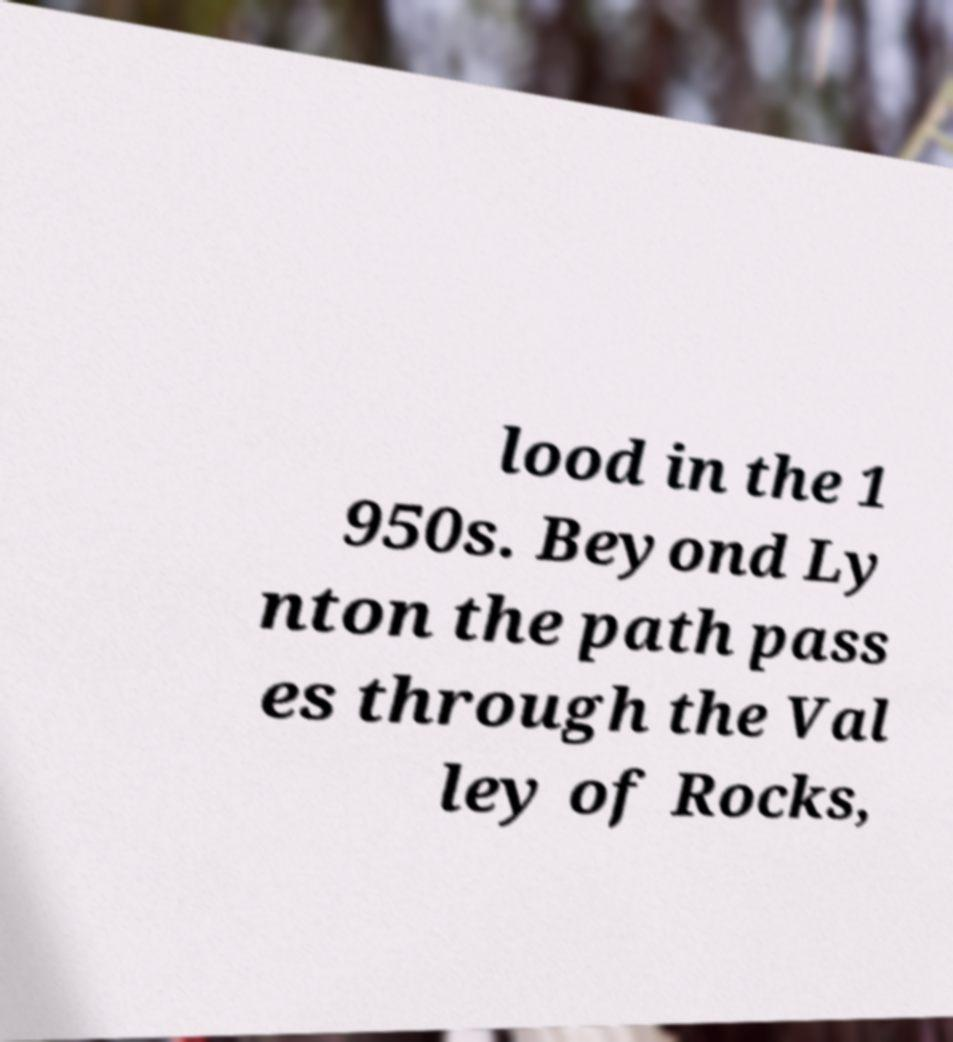I need the written content from this picture converted into text. Can you do that? lood in the 1 950s. Beyond Ly nton the path pass es through the Val ley of Rocks, 